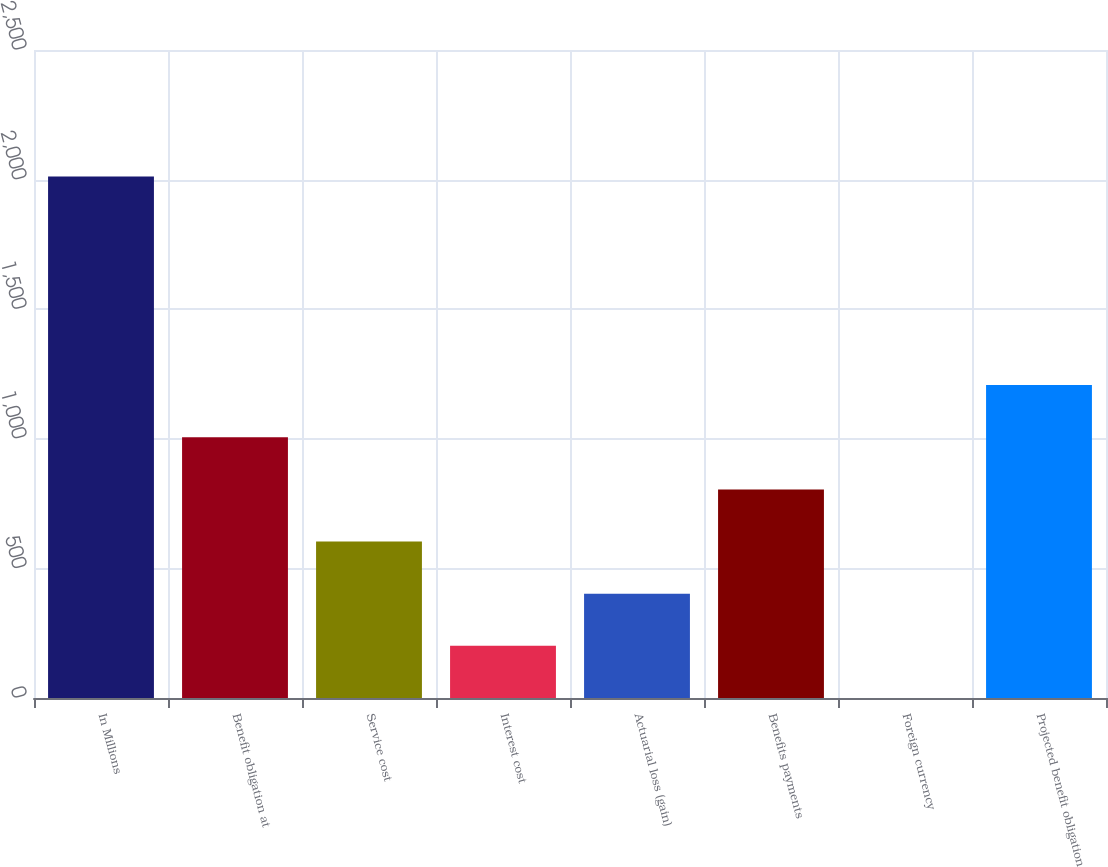Convert chart. <chart><loc_0><loc_0><loc_500><loc_500><bar_chart><fcel>In Millions<fcel>Benefit obligation at<fcel>Service cost<fcel>Interest cost<fcel>Actuarial loss (gain)<fcel>Benefits payments<fcel>Foreign currency<fcel>Projected benefit obligation<nl><fcel>2012<fcel>1006.05<fcel>603.67<fcel>201.29<fcel>402.48<fcel>804.86<fcel>0.1<fcel>1207.24<nl></chart> 